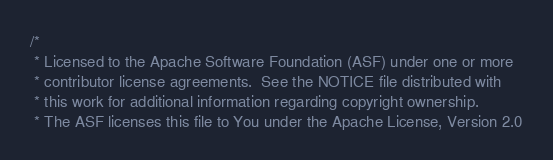<code> <loc_0><loc_0><loc_500><loc_500><_Scala_>/*
 * Licensed to the Apache Software Foundation (ASF) under one or more
 * contributor license agreements.  See the NOTICE file distributed with
 * this work for additional information regarding copyright ownership.
 * The ASF licenses this file to You under the Apache License, Version 2.0</code> 